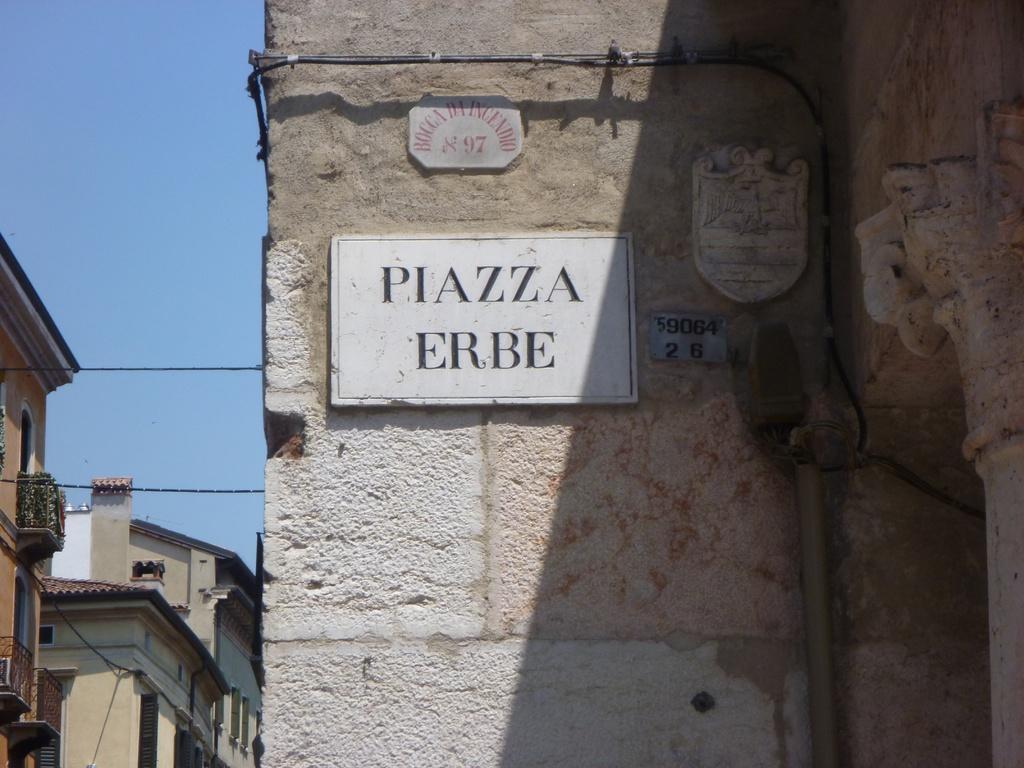Can you describe this image briefly? There is a number plate and name boards, attached to the wall of a building, near cables. In the background, there are electrical lines, there are buildings, and there is blue sky. 